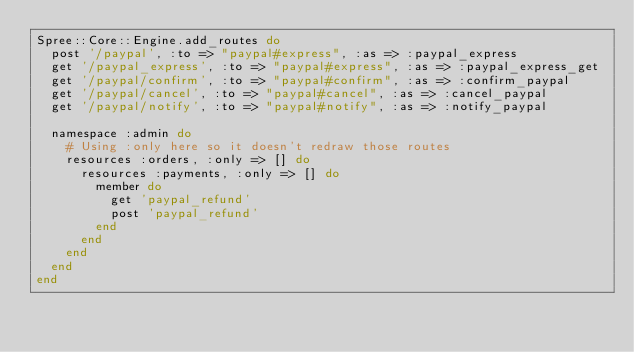Convert code to text. <code><loc_0><loc_0><loc_500><loc_500><_Ruby_>Spree::Core::Engine.add_routes do
  post '/paypal', :to => "paypal#express", :as => :paypal_express
  get '/paypal_express', :to => "paypal#express", :as => :paypal_express_get
  get '/paypal/confirm', :to => "paypal#confirm", :as => :confirm_paypal
  get '/paypal/cancel', :to => "paypal#cancel", :as => :cancel_paypal
  get '/paypal/notify', :to => "paypal#notify", :as => :notify_paypal

  namespace :admin do
    # Using :only here so it doesn't redraw those routes
    resources :orders, :only => [] do
      resources :payments, :only => [] do
        member do
          get 'paypal_refund'
          post 'paypal_refund'
        end
      end
    end
  end
end</code> 